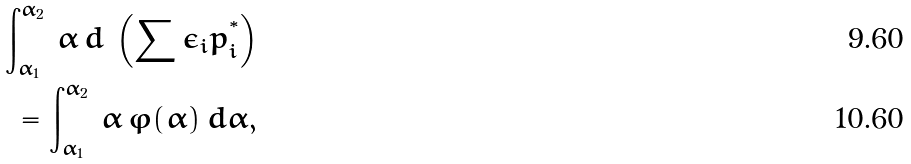<formula> <loc_0><loc_0><loc_500><loc_500>\int ^ { \alpha _ { 2 } } _ { \alpha _ { 1 } } \, \alpha \, d \, \left ( \sum \epsilon _ { i } p _ { i } ^ { ^ { * } } \right ) \\ = \int ^ { \alpha _ { 2 } } _ { \alpha _ { 1 } } \, \alpha \, \varphi ( \alpha ) \, d \alpha ,</formula> 